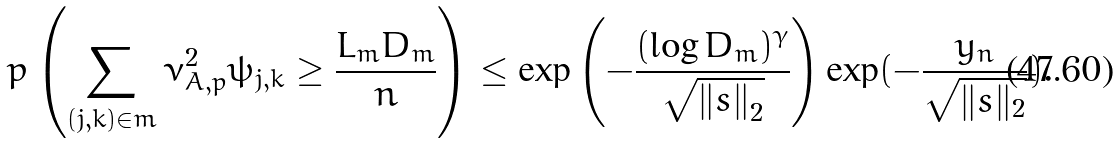Convert formula to latex. <formula><loc_0><loc_0><loc_500><loc_500>\ p \left ( \sum _ { ( j , k ) \in m } \bar { \nu } _ { A , p } ^ { 2 } \bar { \psi } _ { j , k } \geq \frac { L _ { m } D _ { m } } { n } \right ) \leq \exp \left ( - \frac { ( \log D _ { m } ) ^ { \gamma } } { \sqrt { \left \| s \right \| _ { 2 } } } \right ) \exp ( - \frac { y _ { n } } { \sqrt { \| s \| _ { 2 } } } ) .</formula> 